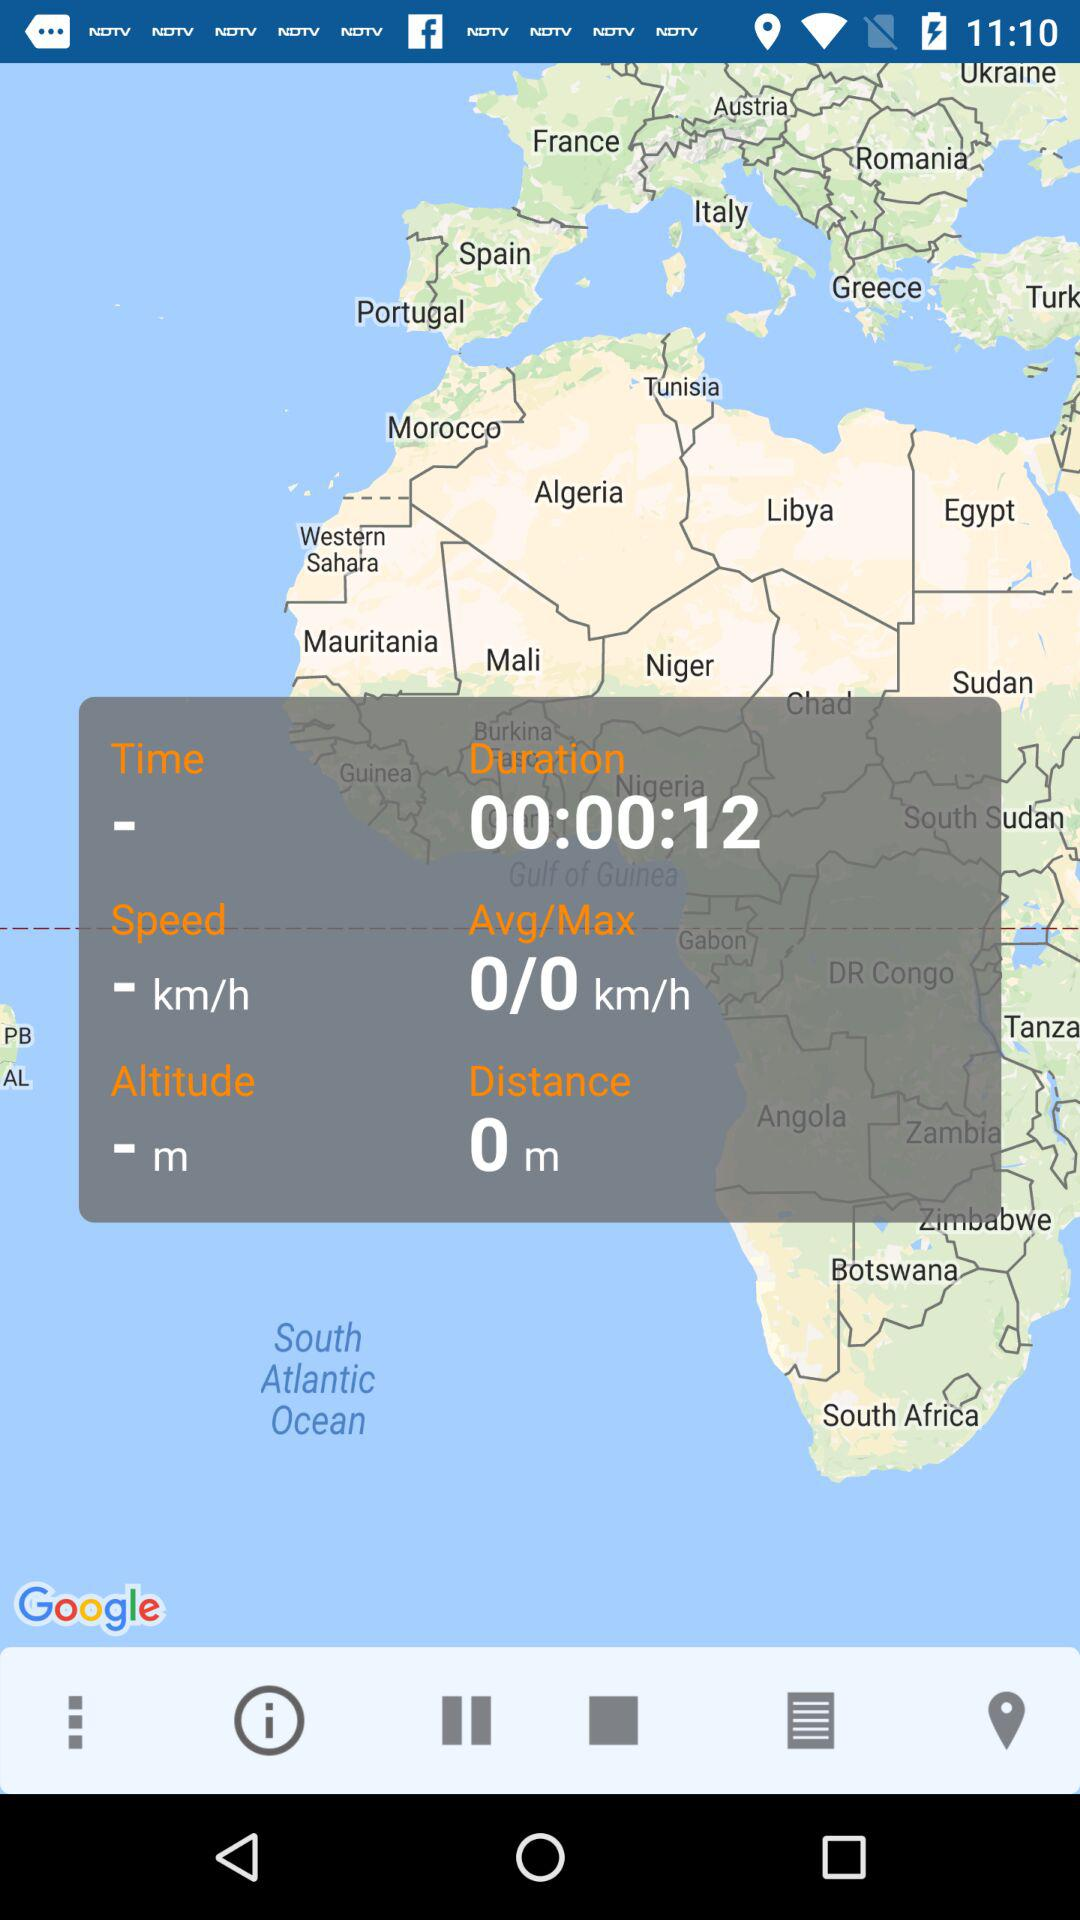What is the traveled distance? The traveled distance is 0 meters. 